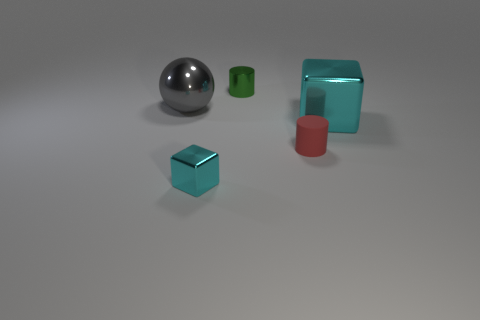Add 3 small gray shiny objects. How many objects exist? 8 Subtract all spheres. How many objects are left? 4 Add 2 tiny cyan things. How many tiny cyan things are left? 3 Add 5 cylinders. How many cylinders exist? 7 Subtract 0 green balls. How many objects are left? 5 Subtract all tiny red rubber things. Subtract all matte things. How many objects are left? 3 